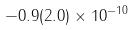Convert formula to latex. <formula><loc_0><loc_0><loc_500><loc_500>- 0 . 9 ( 2 . 0 ) \times 1 0 ^ { - 1 0 }</formula> 